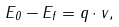<formula> <loc_0><loc_0><loc_500><loc_500>E _ { 0 } - E _ { f } = { q } \cdot { v } ,</formula> 